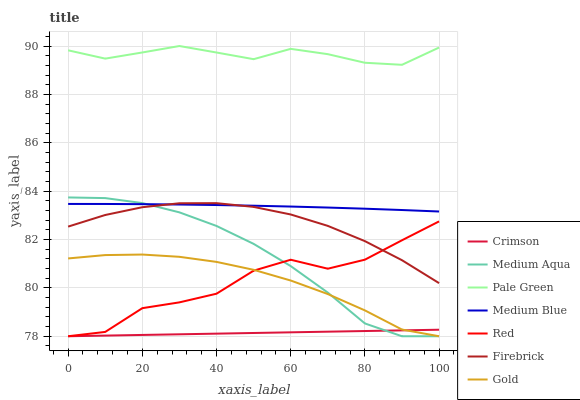Does Crimson have the minimum area under the curve?
Answer yes or no. Yes. Does Pale Green have the maximum area under the curve?
Answer yes or no. Yes. Does Firebrick have the minimum area under the curve?
Answer yes or no. No. Does Firebrick have the maximum area under the curve?
Answer yes or no. No. Is Crimson the smoothest?
Answer yes or no. Yes. Is Red the roughest?
Answer yes or no. Yes. Is Firebrick the smoothest?
Answer yes or no. No. Is Firebrick the roughest?
Answer yes or no. No. Does Gold have the lowest value?
Answer yes or no. Yes. Does Firebrick have the lowest value?
Answer yes or no. No. Does Pale Green have the highest value?
Answer yes or no. Yes. Does Firebrick have the highest value?
Answer yes or no. No. Is Red less than Pale Green?
Answer yes or no. Yes. Is Pale Green greater than Firebrick?
Answer yes or no. Yes. Does Medium Aqua intersect Red?
Answer yes or no. Yes. Is Medium Aqua less than Red?
Answer yes or no. No. Is Medium Aqua greater than Red?
Answer yes or no. No. Does Red intersect Pale Green?
Answer yes or no. No. 